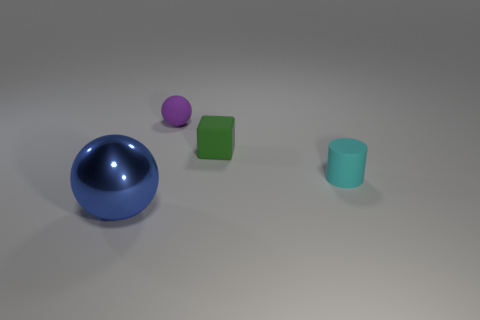Add 4 green things. How many objects exist? 8 Subtract all cylinders. How many objects are left? 3 Add 1 big blue metal objects. How many big blue metal objects are left? 2 Add 3 small matte cylinders. How many small matte cylinders exist? 4 Subtract 0 blue blocks. How many objects are left? 4 Subtract all big blue cylinders. Subtract all purple balls. How many objects are left? 3 